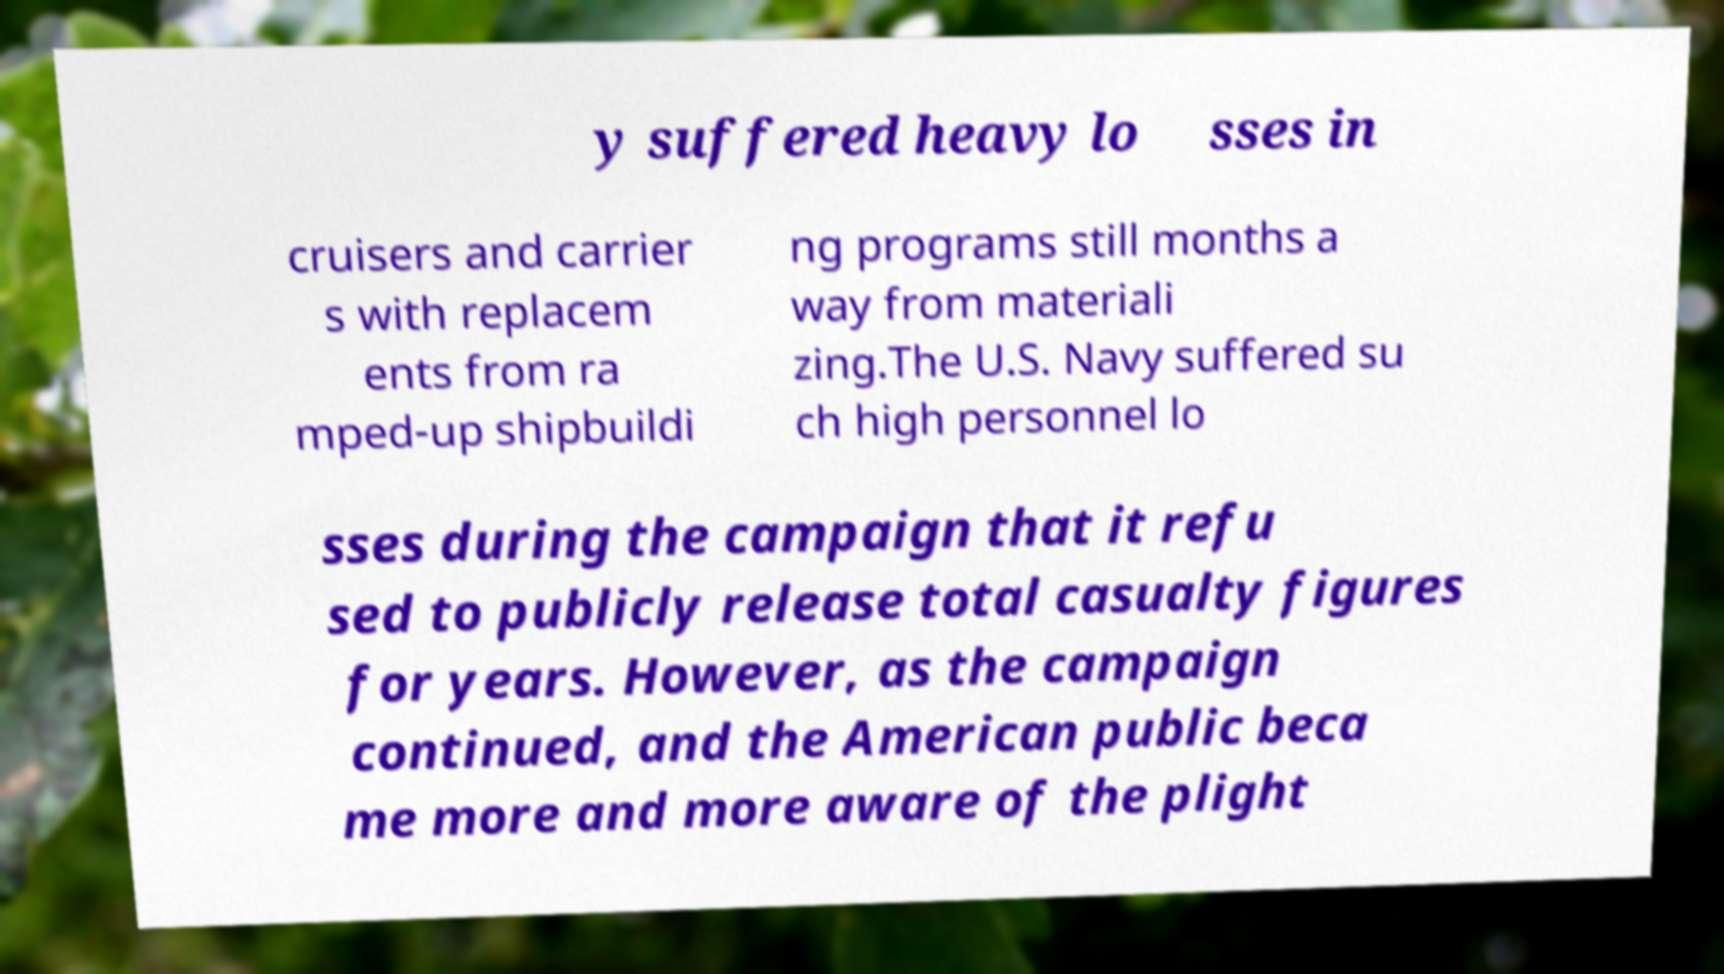Please identify and transcribe the text found in this image. y suffered heavy lo sses in cruisers and carrier s with replacem ents from ra mped-up shipbuildi ng programs still months a way from materiali zing.The U.S. Navy suffered su ch high personnel lo sses during the campaign that it refu sed to publicly release total casualty figures for years. However, as the campaign continued, and the American public beca me more and more aware of the plight 